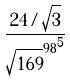<formula> <loc_0><loc_0><loc_500><loc_500>\frac { 2 4 / \sqrt { 3 } } { { \sqrt { 1 6 9 } ^ { 9 8 } } ^ { 5 } }</formula> 